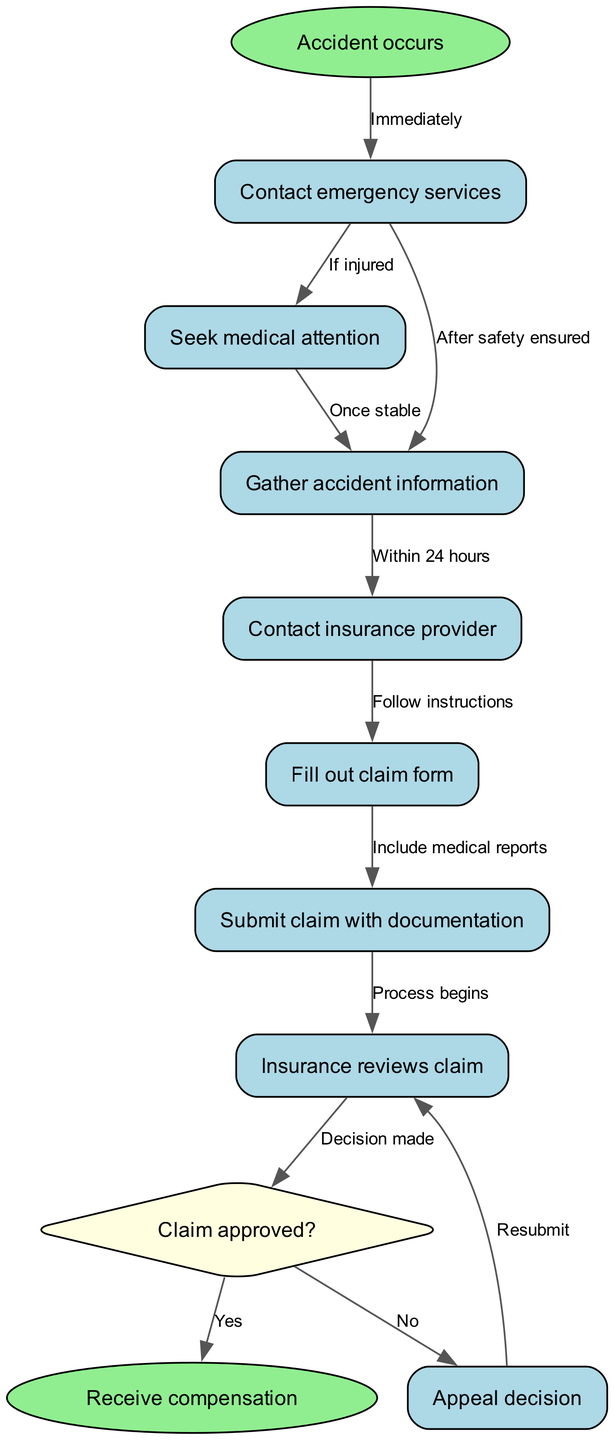What is the first action taken after an accident occurs? The first action taken according to the diagram is to "Contact emergency services" immediately after the accident occurs.
Answer: Contact emergency services What node follows "Seek medical attention"? The node that follows "Seek medical attention" is "Gather accident information", which shows the next step after seeking medical help.
Answer: Gather accident information How many edges connect to the "Claim approved?" decision node? There are two edges connecting to the "Claim approved?" decision node, representing the outcomes of the claim review: "Yes" and "No".
Answer: Two What happens if the claim is denied? If the claim is denied, you can "Appeal decision", which leads back to the insurance review process, allowing for a resubmission of the claim.
Answer: Appeal decision What action should be taken within 24 hours after an accident? The action to be taken within 24 hours after an accident is to "Gather accident information" and then "Contact insurance provider" as per the flowchart.
Answer: Gather accident information and contact insurance provider How does the process begin after submitting a claim? The process begins with "Insurance reviews claim", indicating that the claim submissions are examined by the insurance provider after all documentation is submitted.
Answer: Insurance reviews claim What kind of node is the "Claim approved?" node? The "Claim approved?" node is a decision node, indicated by its diamond shape in the flowchart, representing the critical decision point in the claims process.
Answer: Decision node What is the significance of including medical reports when filling out the claim form? Including medical reports is significant because it provides essential documentation to support the claim, which is required when you "Submit claim with documentation".
Answer: Essential documentation What action follows "Contact insurance provider"? The action that follows "Contact insurance provider" is to "Fill out claim form", demonstrating the sequence in the claims process.
Answer: Fill out claim form What color indicates a starting point in the diagram? The starting point, indicated by "Accident occurs", is colored light green, which signifies the initial step in the flowchart.
Answer: Light green 